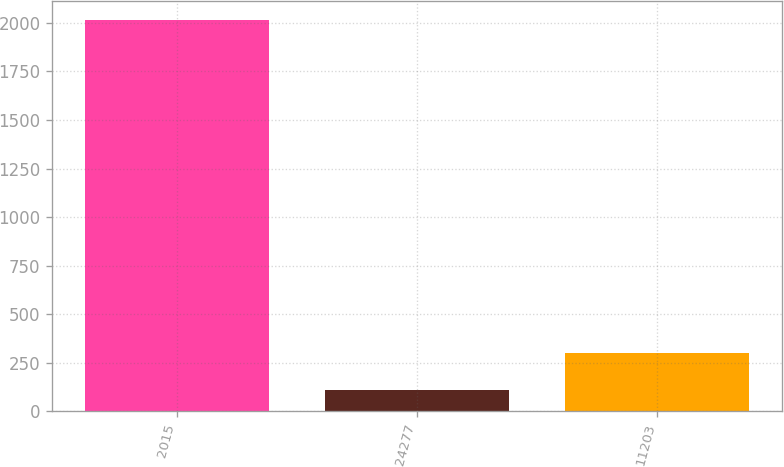<chart> <loc_0><loc_0><loc_500><loc_500><bar_chart><fcel>2015<fcel>24277<fcel>11203<nl><fcel>2015<fcel>106.6<fcel>297.44<nl></chart> 